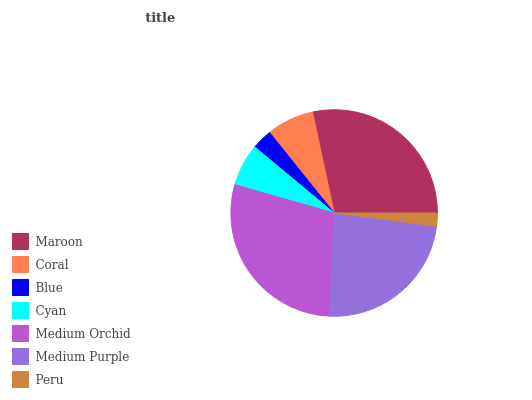Is Peru the minimum?
Answer yes or no. Yes. Is Medium Orchid the maximum?
Answer yes or no. Yes. Is Coral the minimum?
Answer yes or no. No. Is Coral the maximum?
Answer yes or no. No. Is Maroon greater than Coral?
Answer yes or no. Yes. Is Coral less than Maroon?
Answer yes or no. Yes. Is Coral greater than Maroon?
Answer yes or no. No. Is Maroon less than Coral?
Answer yes or no. No. Is Coral the high median?
Answer yes or no. Yes. Is Coral the low median?
Answer yes or no. Yes. Is Maroon the high median?
Answer yes or no. No. Is Medium Orchid the low median?
Answer yes or no. No. 